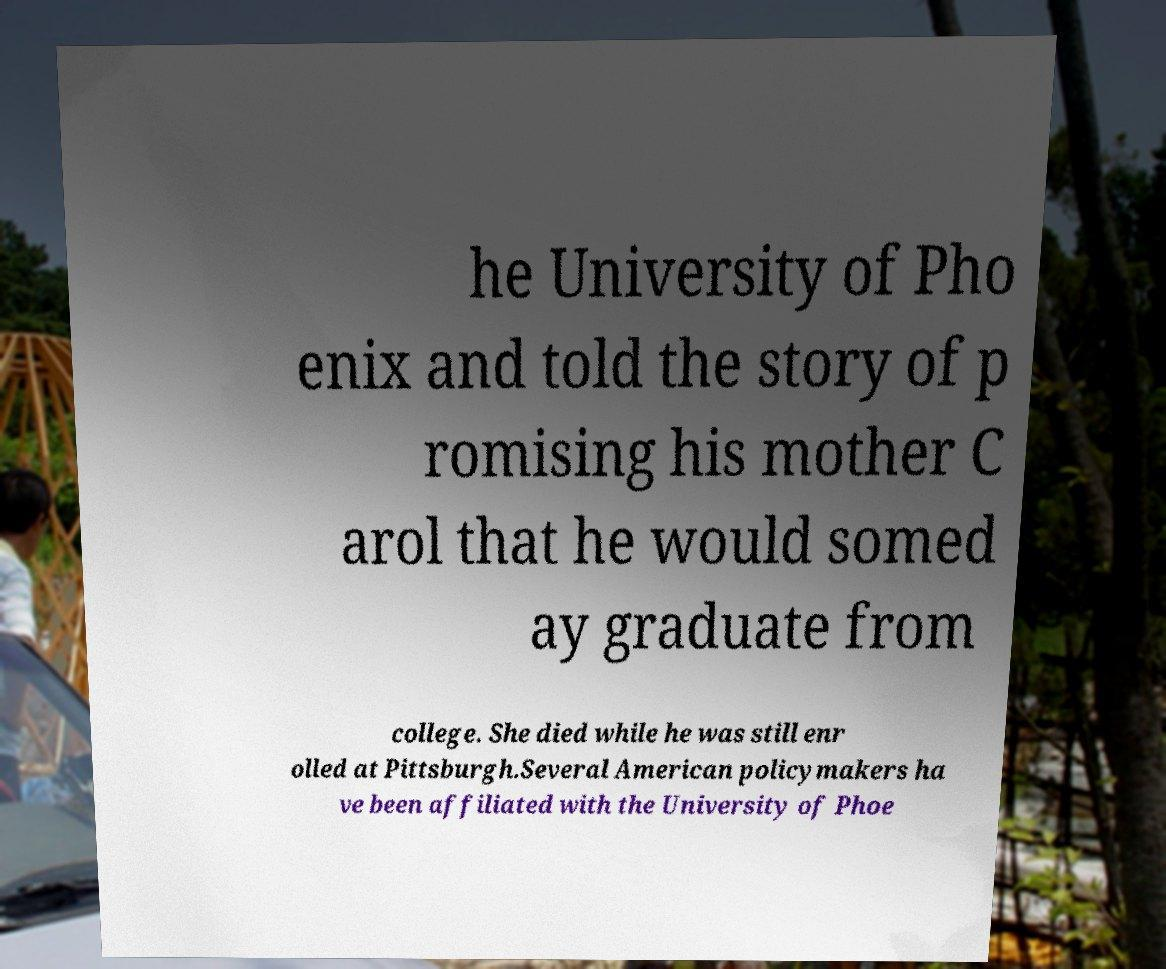Could you assist in decoding the text presented in this image and type it out clearly? he University of Pho enix and told the story of p romising his mother C arol that he would somed ay graduate from college. She died while he was still enr olled at Pittsburgh.Several American policymakers ha ve been affiliated with the University of Phoe 